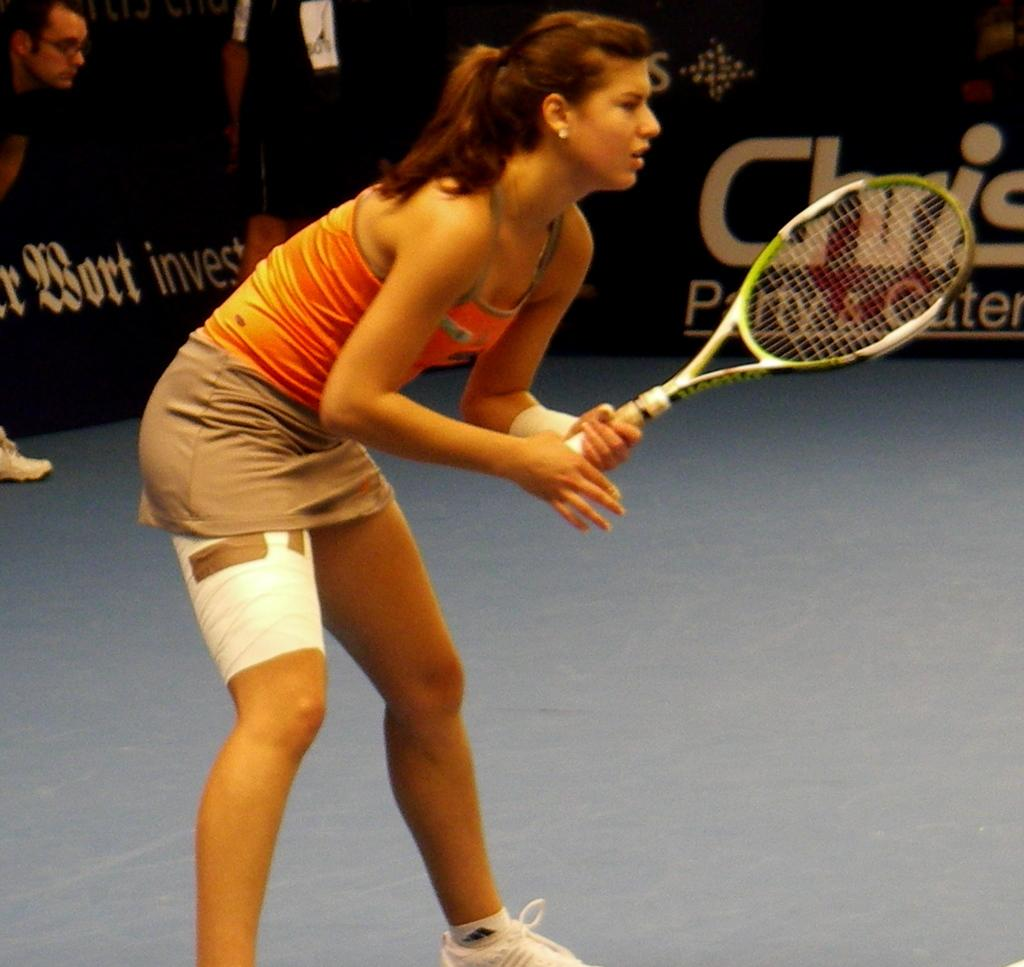What is the woman in the image holding? The woman is holding a racket in the image. How many people are present in the image? There are two people standing in the image. What is the woman wearing on her feet? The woman is wearing white shoes in the image. What can be seen at the back side of the image? There is a board at the back side of the image. What type of wrench is the woman using in the image? There is no wrench present in the image; the woman is holding a racket. Can you see a pencil in the woman's hand in the image? No, there is no pencil visible in the image; the woman is holding a racket. Is there a squirrel visible in the image? No, there is no squirrel present in the image. 